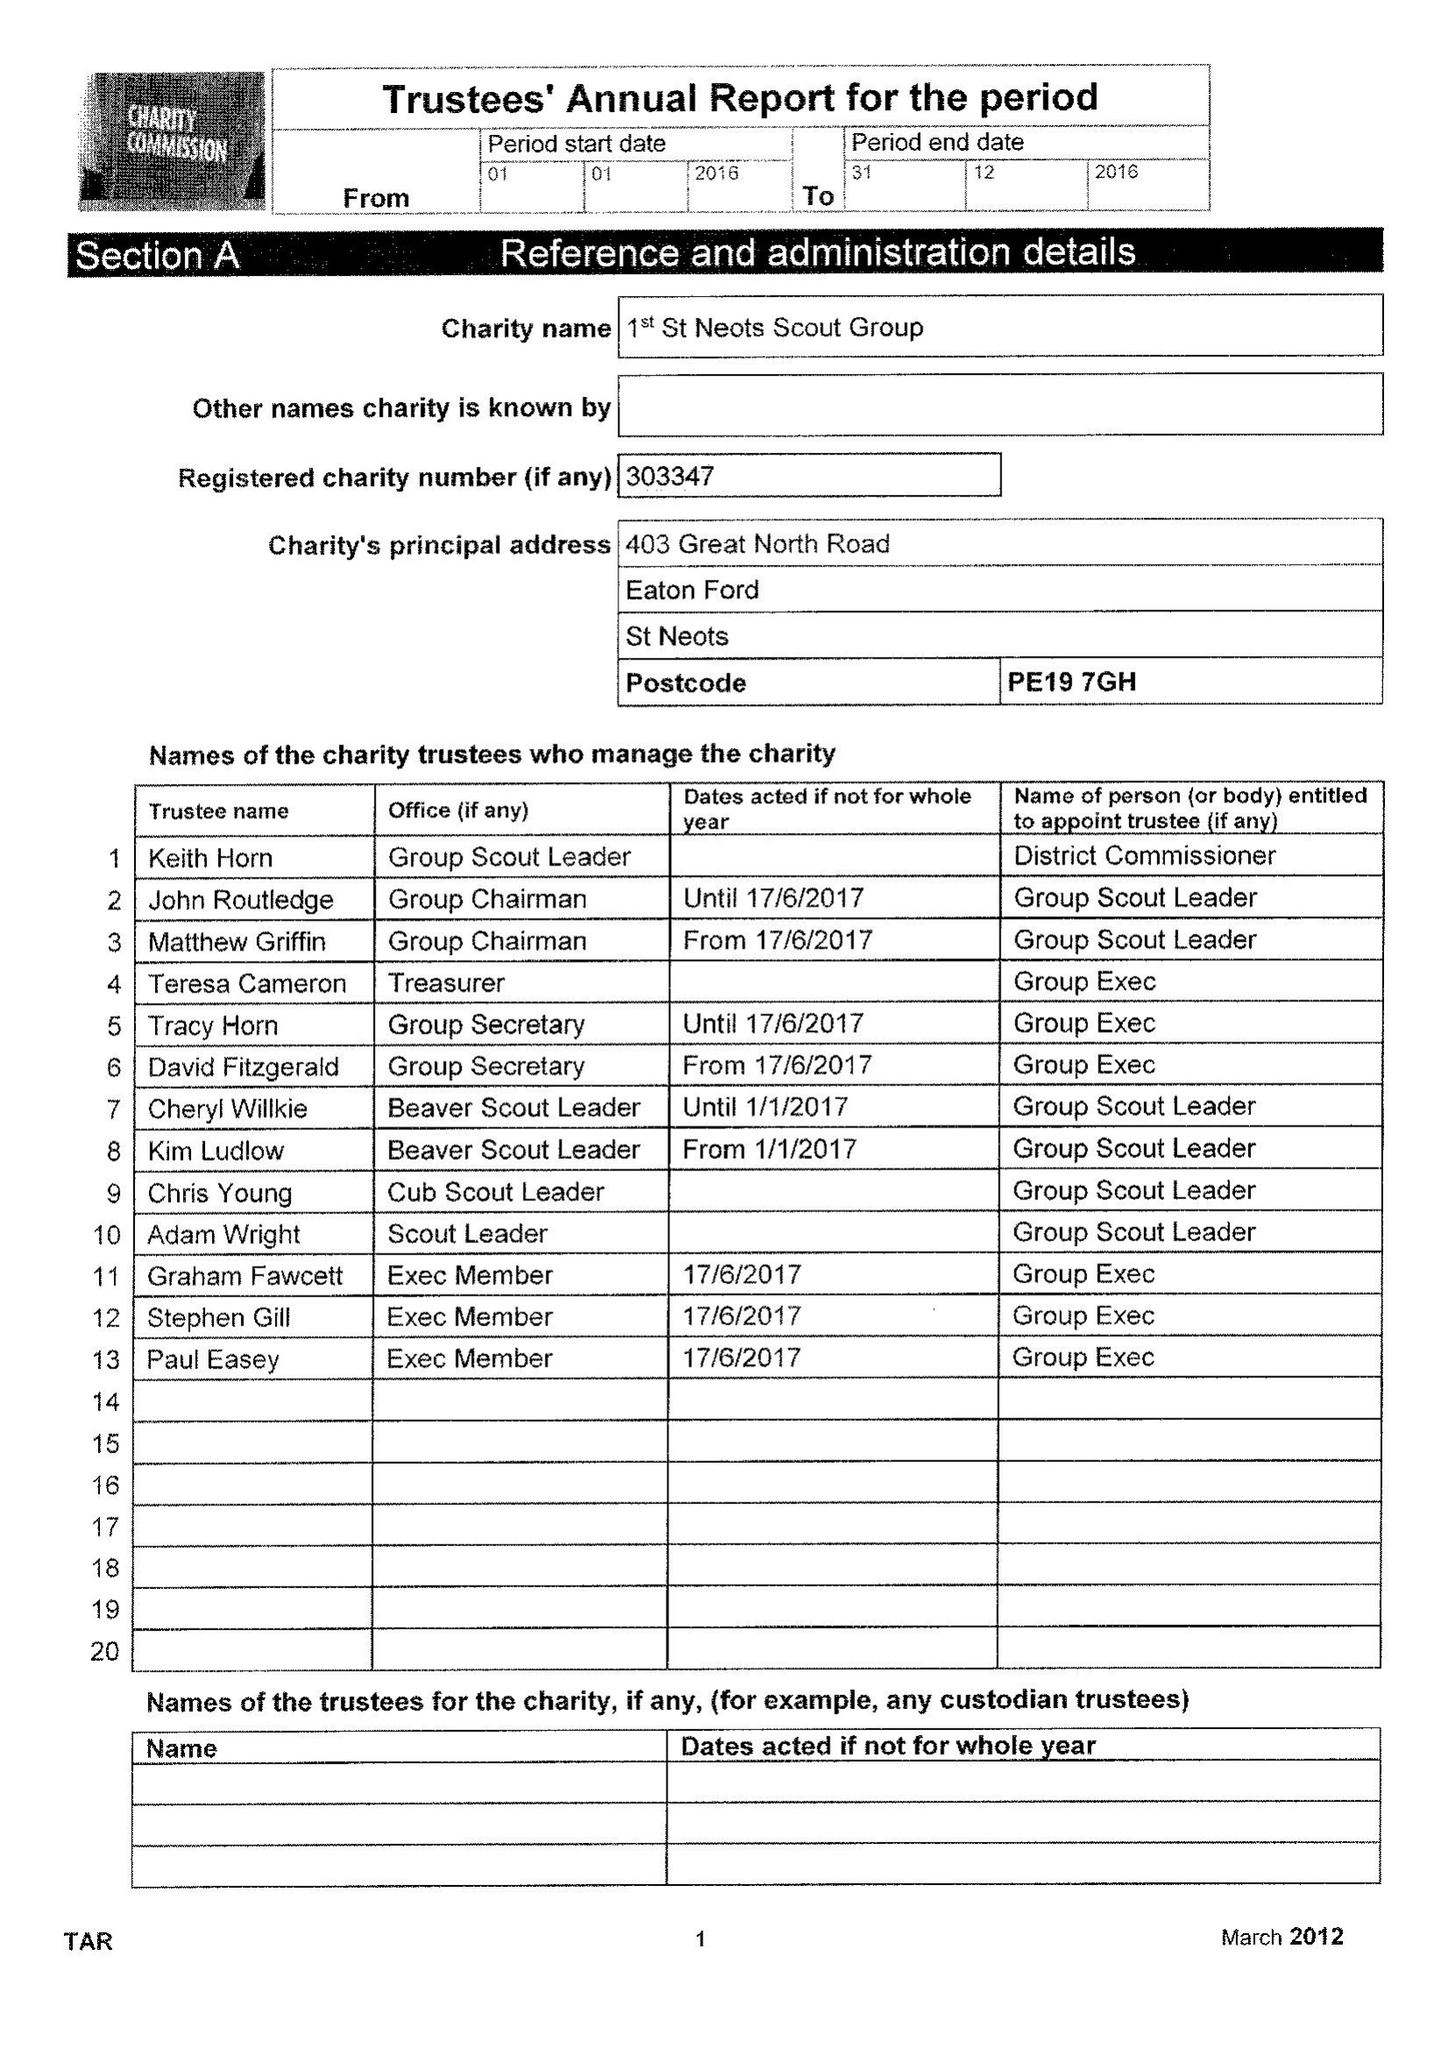What is the value for the report_date?
Answer the question using a single word or phrase. 2016-12-31 